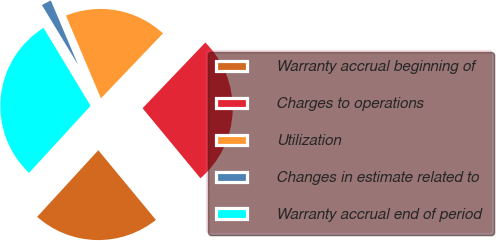Convert chart to OTSL. <chart><loc_0><loc_0><loc_500><loc_500><pie_chart><fcel>Warranty accrual beginning of<fcel>Charges to operations<fcel>Utilization<fcel>Changes in estimate related to<fcel>Warranty accrual end of period<nl><fcel>22.81%<fcel>26.87%<fcel>18.5%<fcel>2.28%<fcel>29.53%<nl></chart> 